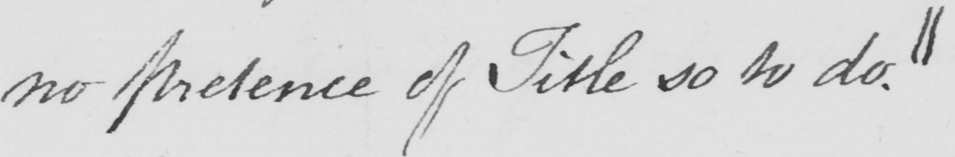Please provide the text content of this handwritten line. no pretence of Title so to do . || 